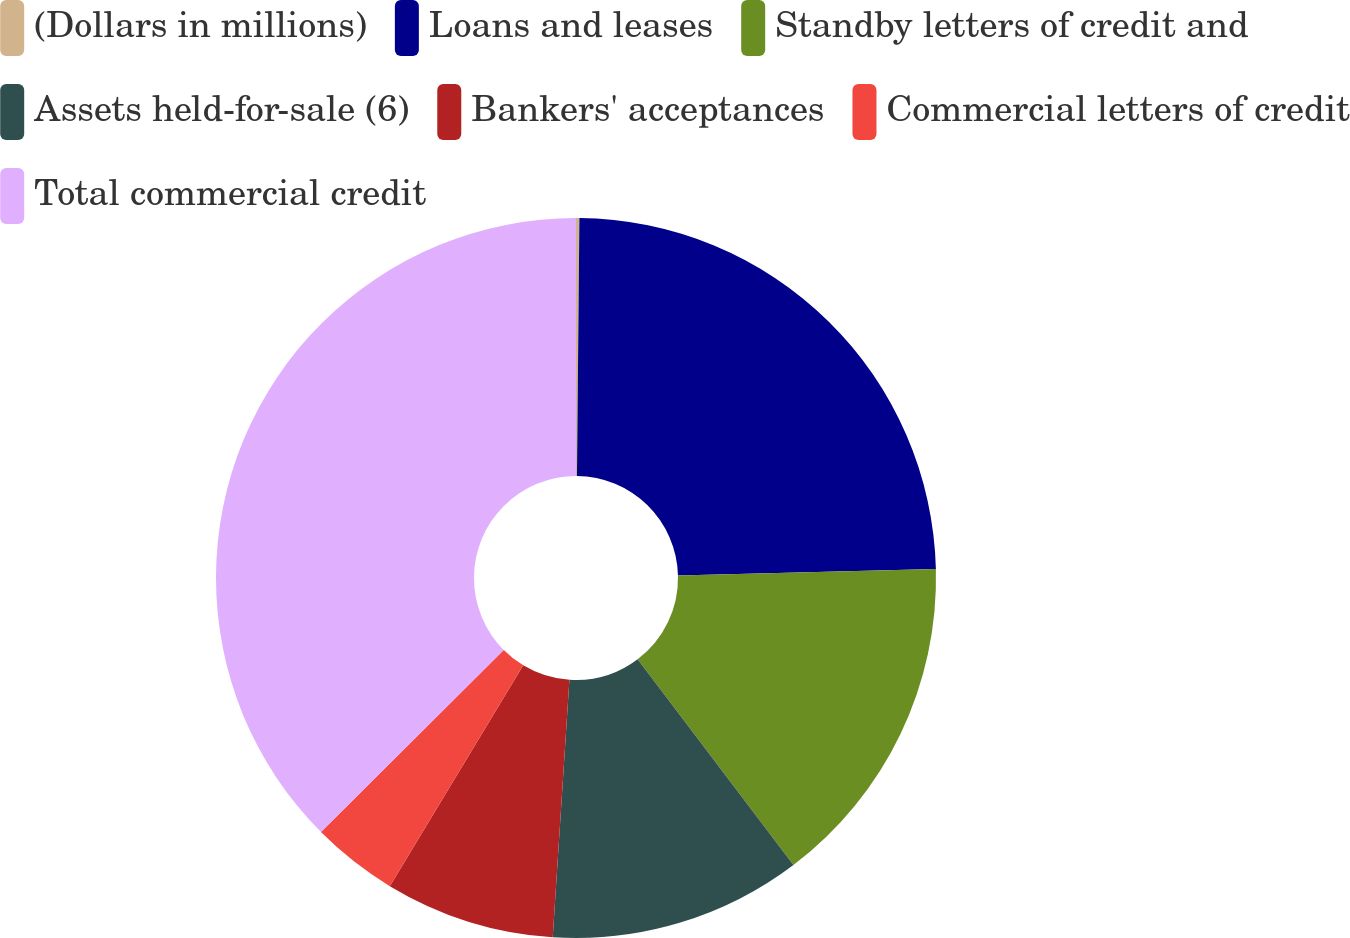<chart> <loc_0><loc_0><loc_500><loc_500><pie_chart><fcel>(Dollars in millions)<fcel>Loans and leases<fcel>Standby letters of credit and<fcel>Assets held-for-sale (6)<fcel>Bankers' acceptances<fcel>Commercial letters of credit<fcel>Total commercial credit<nl><fcel>0.15%<fcel>24.45%<fcel>15.08%<fcel>11.35%<fcel>7.62%<fcel>3.88%<fcel>37.47%<nl></chart> 